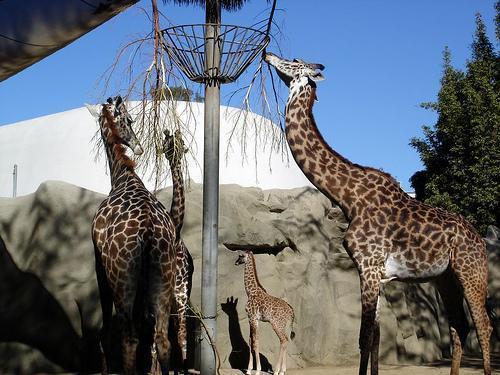How many animals?
Give a very brief answer. 4. How many giraffes are in the picture?
Give a very brief answer. 4. How many people are in the picture?
Give a very brief answer. 0. 